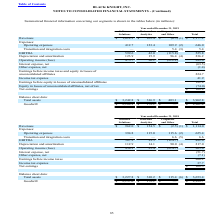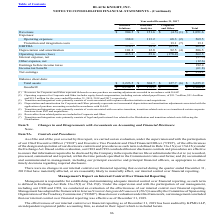According to Black Knight Financial Services's financial document, What did revenues for Corporate and Other represent? deferred revenue purchase accounting adjustments recorded in accordance with GAAP.. The document states: "___ (1) Revenues for Corporate and Other represent deferred revenue purchase accounting adjustments recorded in accordance with GAAP...." Also, What were the operating expenses for Software Solutions? According to the financial document, 394.8 (in millions). The relevant text states: "Operating expenses 394.8 115.0 115.6 (2) 625.4..." Also, What were the total Transition and integration costs? According to the financial document, 6.6 (in millions). The relevant text states: "Transition and integration costs — — 6.6 (5) 6.6..." Also, can you calculate: What was the difference in the EBITDA between Software Solutions and Data and Analytics? Based on the calculation: 567.2-39.5, the result is 527.7 (in millions). This is based on the information: "EBITDA 567.2 39.5 (124.7) 482.0 EBITDA 567.2 39.5 (124.7) 482.0..." The key data points involved are: 39.5, 567.2. Also, can you calculate: What was the difference between Total Assets and Total Goodwill? Based on the calculation: 3,653.4-2,329.7, the result is 1323.7 (in millions). This is based on the information: "Goodwill $ 2,157.6 $ 172.1 $ — $ 2,329.7 Total assets $ 3,227.8 $ 310.2 $ 115.4 (6) $ 3,653.4..." The key data points involved are: 2,329.7, 3,653.4. Also, can you calculate: What was the difference in Depreciation and amortization between Software Solutions and Corporate and Other? Based on the calculation: 112.9-90.0, the result is 22.9 (in millions). This is based on the information: "Depreciation and amortization 112.9 14.1 90.0 (4) 217.0 Depreciation and amortization 112.9 14.1 90.0 (4) 217.0..." The key data points involved are: 112.9, 90.0. 